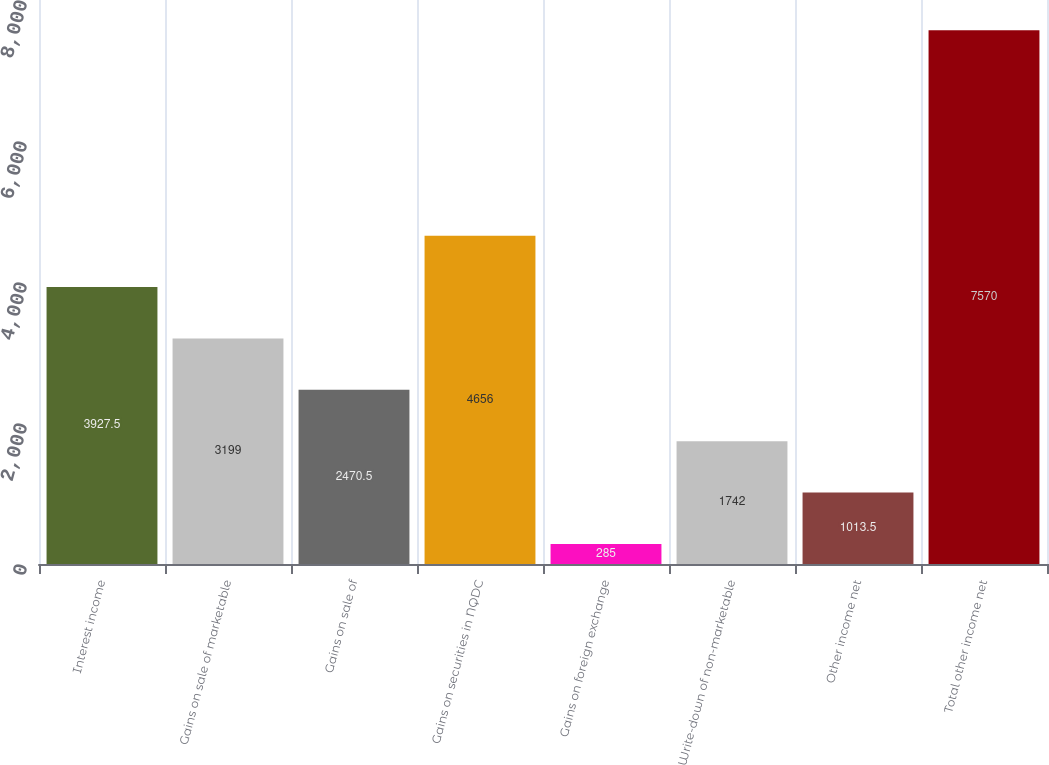Convert chart to OTSL. <chart><loc_0><loc_0><loc_500><loc_500><bar_chart><fcel>Interest income<fcel>Gains on sale of marketable<fcel>Gains on sale of<fcel>Gains on securities in NQDC<fcel>Gains on foreign exchange<fcel>Write-down of non-marketable<fcel>Other income net<fcel>Total other income net<nl><fcel>3927.5<fcel>3199<fcel>2470.5<fcel>4656<fcel>285<fcel>1742<fcel>1013.5<fcel>7570<nl></chart> 